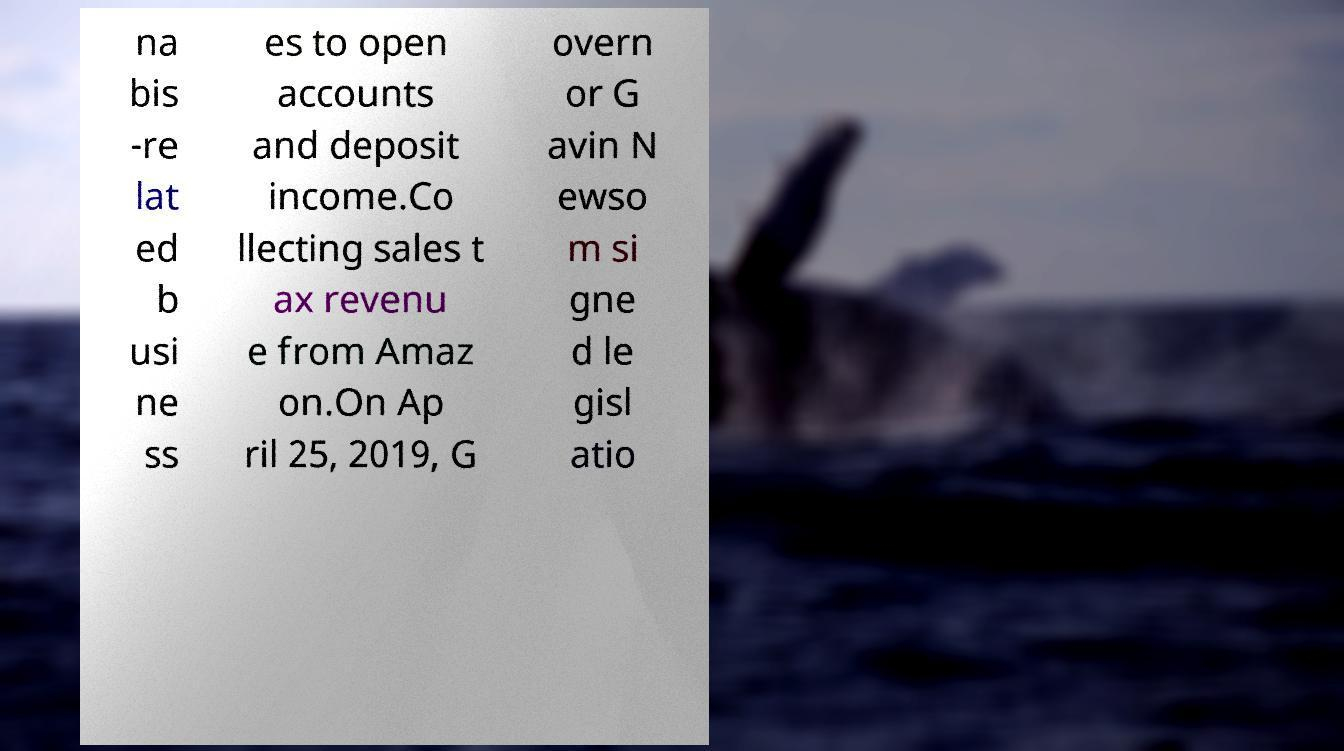What messages or text are displayed in this image? I need them in a readable, typed format. na bis -re lat ed b usi ne ss es to open accounts and deposit income.Co llecting sales t ax revenu e from Amaz on.On Ap ril 25, 2019, G overn or G avin N ewso m si gne d le gisl atio 